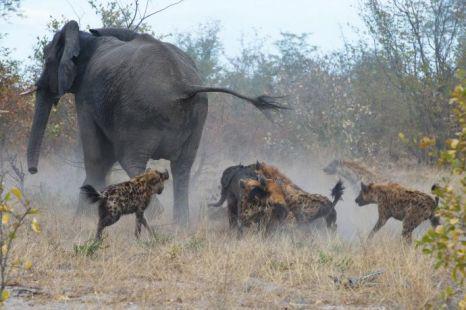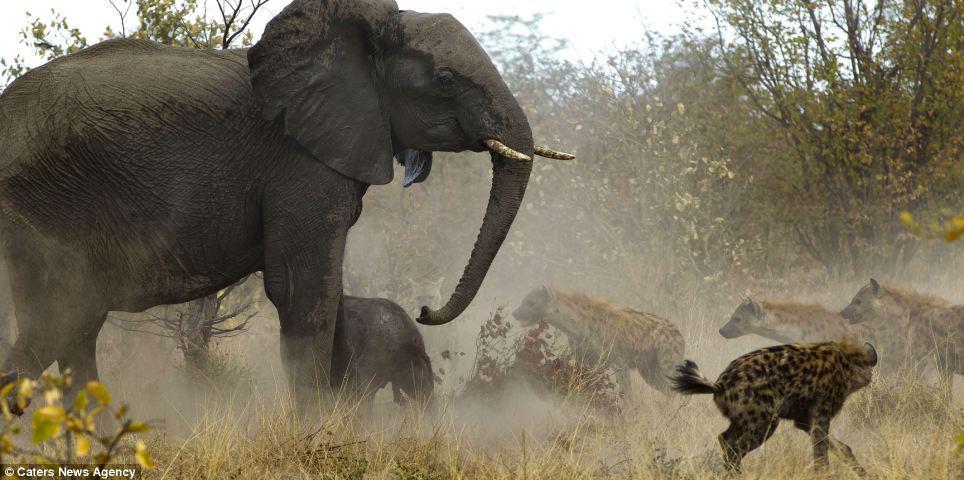The first image is the image on the left, the second image is the image on the right. Analyze the images presented: Is the assertion "Each image shows an elephant in a similar forward charging pose near hyenas." valid? Answer yes or no. No. The first image is the image on the left, the second image is the image on the right. Analyze the images presented: Is the assertion "In one of the images, there are more than two hyenas crowding the baby elephant." valid? Answer yes or no. Yes. 